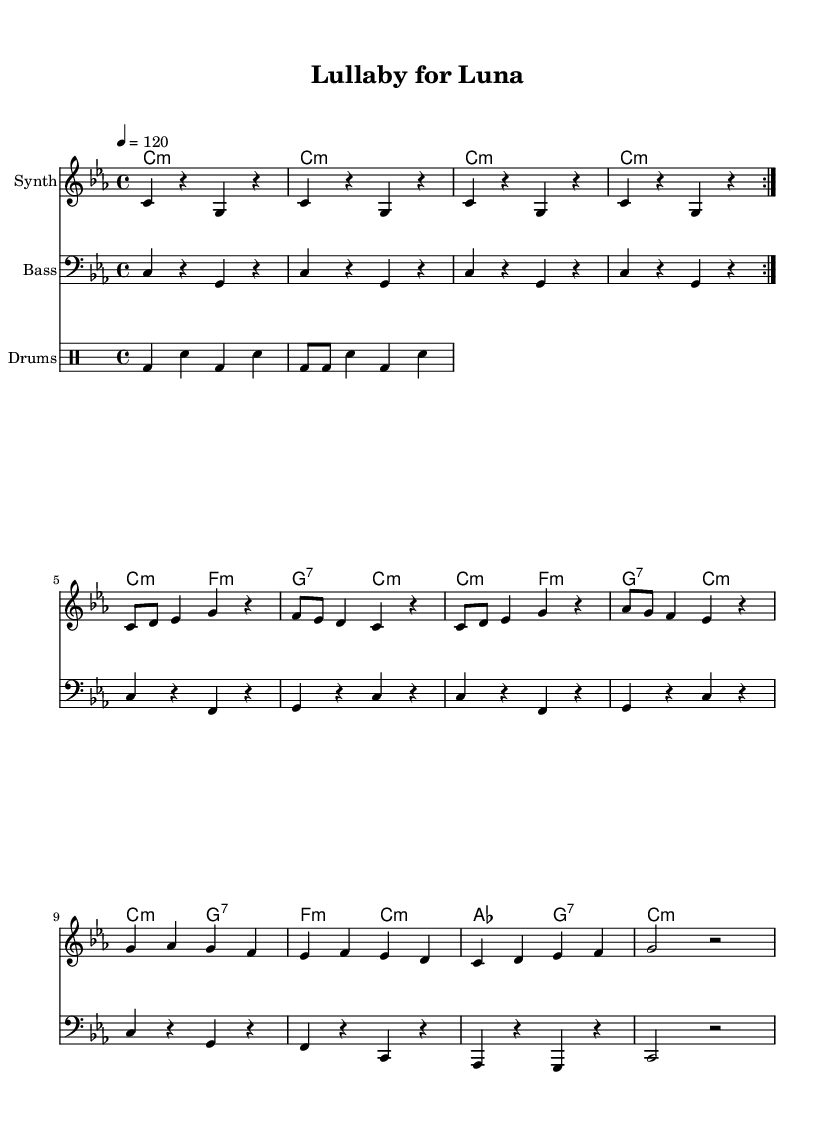What is the key signature of this music? The key signature is indicated in the global section at the beginning of the music, where it states "c minor." This means there are three flats: B flat, E flat, and A flat.
Answer: C minor What is the time signature of this music? The time signature is also found in the global section, where it states "4/4." This indicates that each measure contains four beats, and each beat is a quarter note.
Answer: 4/4 What is the tempo marking of this music? The tempo marking is shown in the global section where it says "4 = 120." This indicates that there are 120 quarter beats per minute, providing a moderate pace for the piece.
Answer: 120 How many times is the main melody repeated? The main melody contains a "volta" marking, indicating that it is repeated twice, as indicated by the "repeat volta 2" instruction in the synthMelody.
Answer: 2 What type of rhythms are employed in the drum pattern? The drum pattern is indicated in the "drummode" section, which shows a combination of bass drum and snare hits, alternating between quarter notes and eighth notes, providing a dance-like groove.
Answer: Bass and snare What is the last note in the melody section? The melody section concludes with a resting note notation ("r") after the note "g2," suggesting a brief pause. The last sounded note before the rest is the note 'g,' which indicates the end of a phrase.
Answer: g Which instruments are included in the score? The score includes three instrumental parts labeled as "Synth," "Bass," and "Drums," each represented in separate staff sections, providing a clear layout for the arrangement.
Answer: Synth, Bass, Drums 